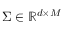<formula> <loc_0><loc_0><loc_500><loc_500>\Sigma \in \mathbb { R } ^ { d \times M }</formula> 